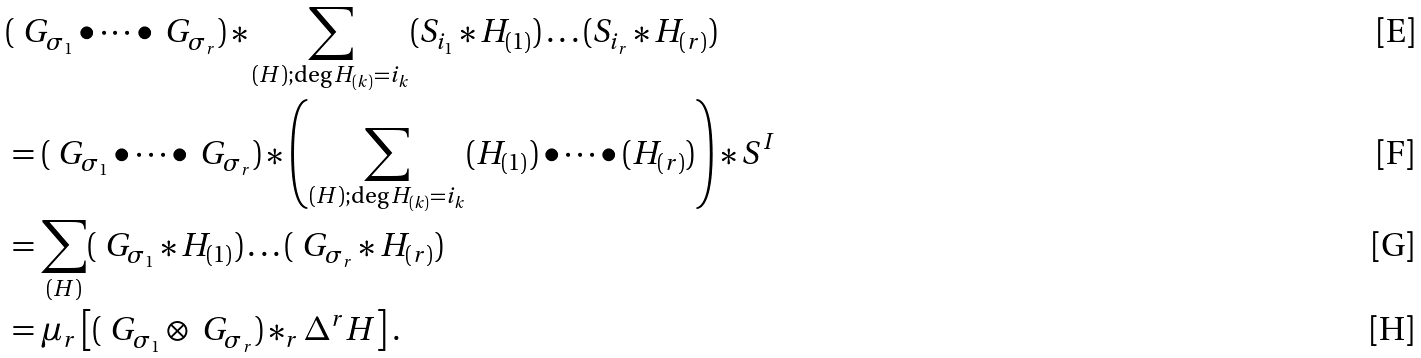Convert formula to latex. <formula><loc_0><loc_0><loc_500><loc_500>& ( \ G _ { \sigma _ { 1 } } \bullet \dots \bullet \ G _ { \sigma _ { r } } ) * \sum _ { ( H ) ; \deg H _ { ( k ) } = i _ { k } } ( S _ { i _ { 1 } } * H _ { ( 1 ) } ) \dots ( S _ { i _ { r } } * H _ { ( r ) } ) \\ & = ( \ G _ { \sigma _ { 1 } } \bullet \dots \bullet \ G _ { \sigma _ { r } } ) * \left ( \sum _ { ( H ) ; \deg H _ { ( k ) } = i _ { k } } ( H _ { ( 1 ) } ) \bullet \dots \bullet ( H _ { ( r ) } ) \right ) * S ^ { I } \\ & = \sum _ { ( H ) } ( \ G _ { \sigma _ { 1 } } * H _ { ( 1 ) } ) \dots ( \ G _ { \sigma _ { r } } * H _ { ( r ) } ) \\ & = \mu _ { r } \left [ ( \ G _ { \sigma _ { 1 } } \otimes \ G _ { \sigma _ { r } } ) * _ { r } \Delta ^ { r } H \right ] .</formula> 